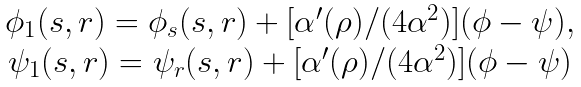<formula> <loc_0><loc_0><loc_500><loc_500>\begin{array} { c } \phi _ { 1 } ( s , r ) = \phi _ { s } ( s , r ) + [ \alpha ^ { \prime } ( \rho ) / ( 4 \alpha ^ { 2 } ) ] ( \phi - \psi ) , \\ \psi _ { 1 } ( s , r ) = \psi _ { r } ( s , r ) + [ \alpha ^ { \prime } ( \rho ) / ( 4 \alpha ^ { 2 } ) ] ( \phi - \psi ) \end{array}</formula> 